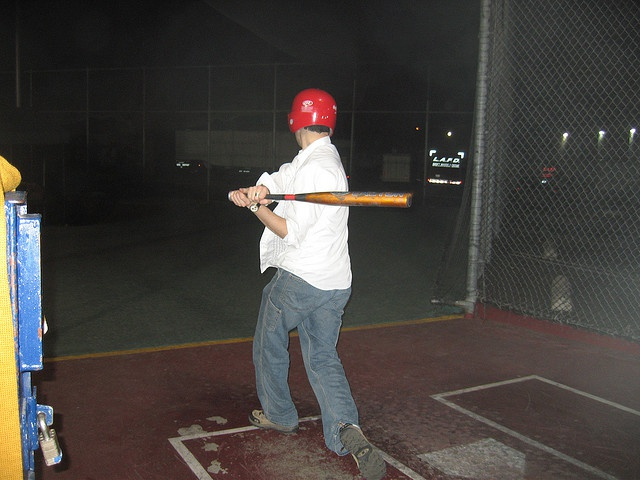Describe the objects in this image and their specific colors. I can see people in black, white, and gray tones and baseball bat in black, orange, brown, and gray tones in this image. 